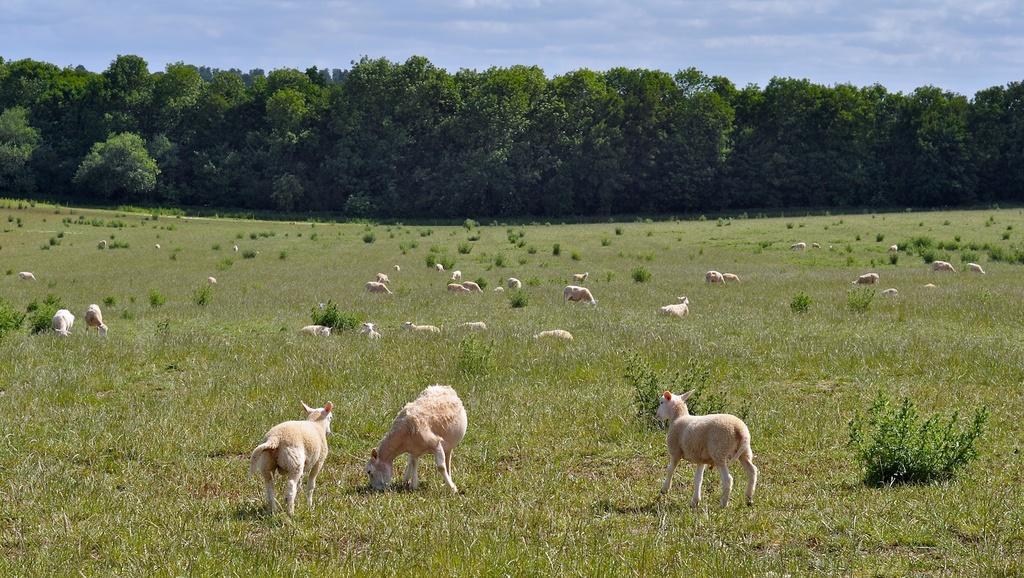How would you summarize this image in a sentence or two? In the middle of the image there are some animals. Behind the animals there is grass. In the middle of the image there are some trees. Behind the trees there are some clouds and sky. 